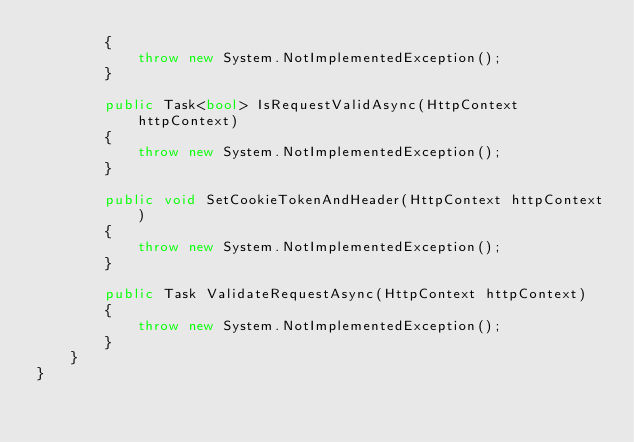Convert code to text. <code><loc_0><loc_0><loc_500><loc_500><_C#_>		{
			throw new System.NotImplementedException();
		}

		public Task<bool> IsRequestValidAsync(HttpContext httpContext)
		{
			throw new System.NotImplementedException();
		}

		public void SetCookieTokenAndHeader(HttpContext httpContext)
		{
			throw new System.NotImplementedException();
		}

		public Task ValidateRequestAsync(HttpContext httpContext)
		{
			throw new System.NotImplementedException();
		}
	}
}
</code> 